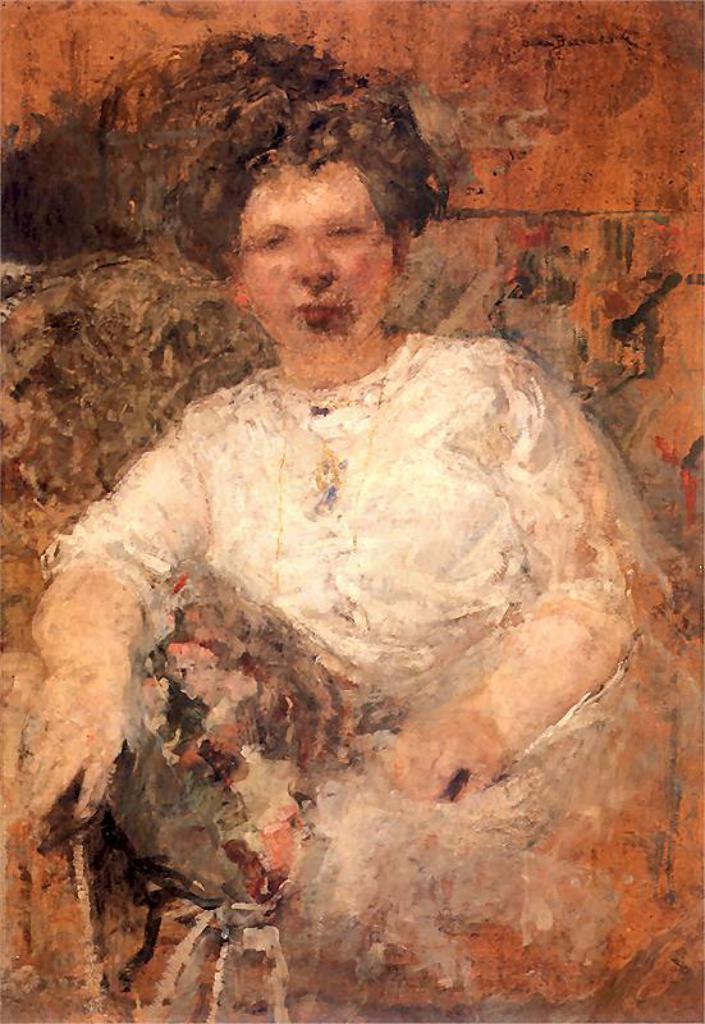Describe this image in one or two sentences. In this image I can see a painting of a woman wearing white colored dress. I can see the painting is white, orange, black, cream and brown in color. 